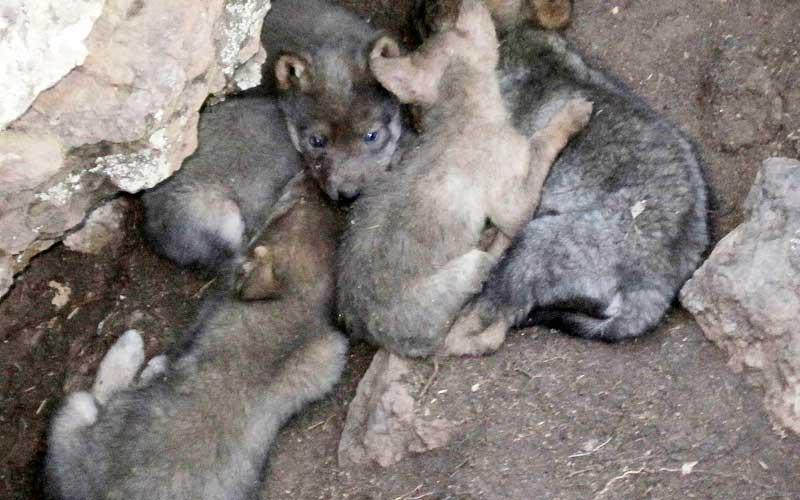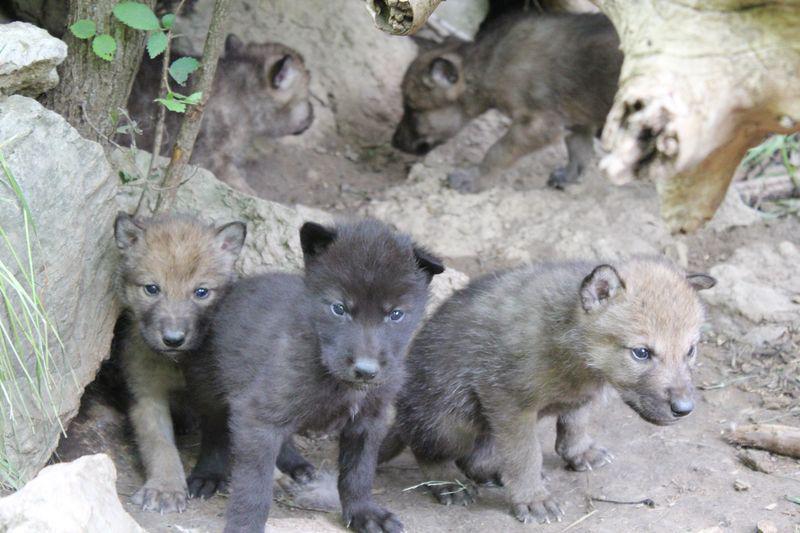The first image is the image on the left, the second image is the image on the right. Examine the images to the left and right. Is the description "One of the images features a single animal." accurate? Answer yes or no. No. The first image is the image on the left, the second image is the image on the right. Given the left and right images, does the statement "There are three wolves in the image pair." hold true? Answer yes or no. No. 